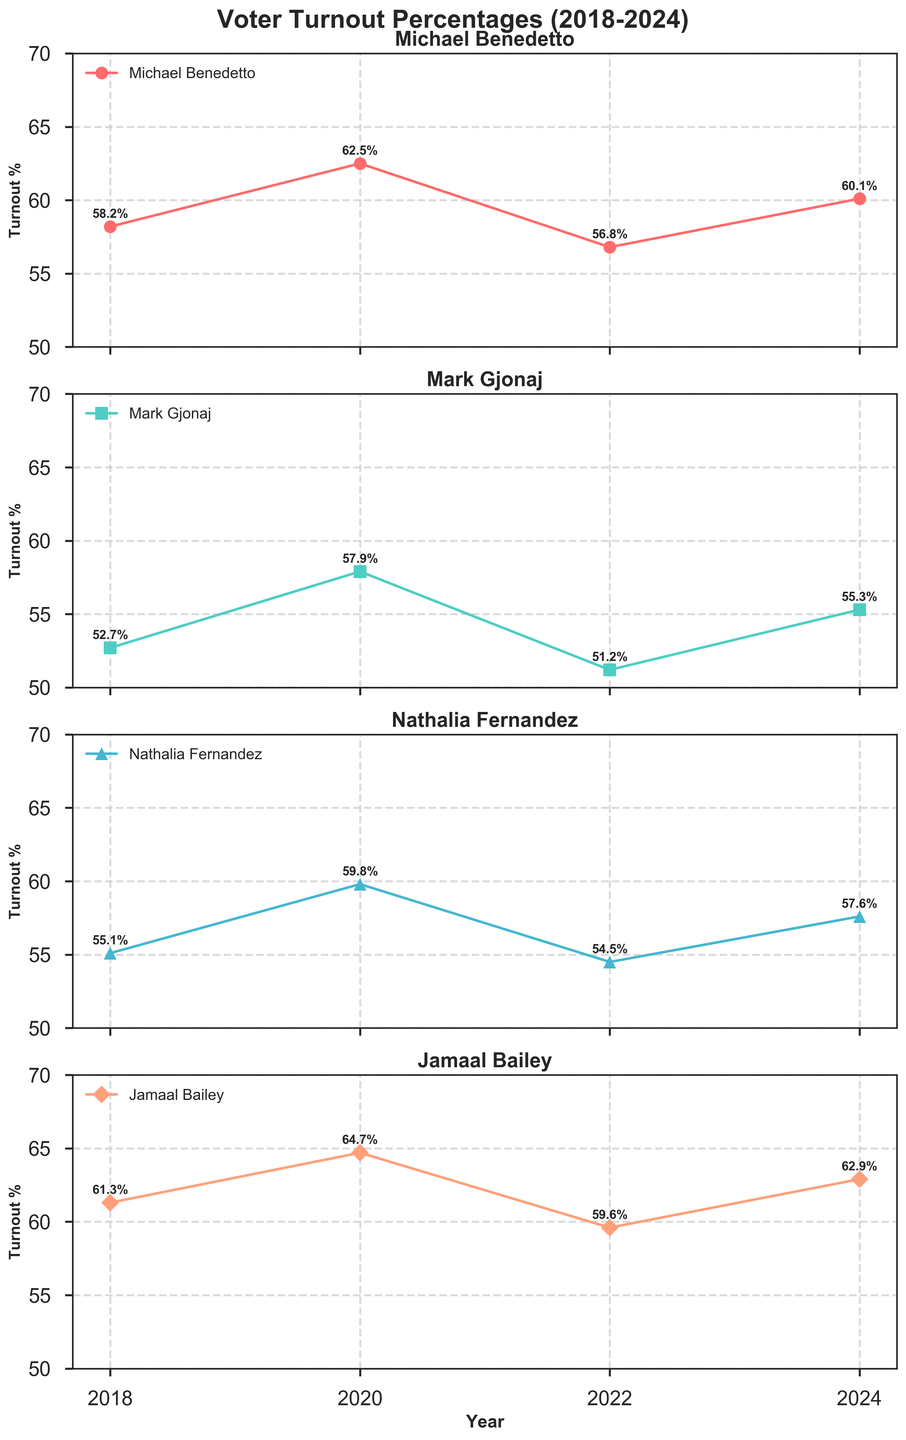What years are covered in the voter turnout data? The x-axis shows the years covered in the data, which are clearly labeled.
Answer: 2018-2024 Which candidate had the highest voter turnout in 2020? In the subplot for 2020, the turnout percentages for all candidates are marked. Jamaal Bailey has the highest percentage.
Answer: Jamaal Bailey By how much did Michael Benedetto's voter turnout change from 2018 to 2022? To find the change, subtract the 2018 turnout percentage (58.2%) from the 2022 turnout percentage (56.8%). This results in a change of -1.4%.
Answer: -1.4% Who had the lowest voter turnout percentage in 2022? Looking at the subplots for 2022, Mark Gjonaj had the lowest turnout percentage.
Answer: Mark Gjonaj What is the average voter turnout for Nathalia Fernandez over the years? Sum the turnout percentages for Nathalia Fernandez over the years and then divide by the number of years: (55.1 + 59.8 + 54.5 + 57.6) / 4 = 56.75%.
Answer: 56.75% Is there any year when Michael Benedetto had the highest voter turnout among all candidates? Compare Michael Benedetto's turnout percentage against other candidates' on the same subplot for each year. In 2020, Jamaal Bailey had the highest turnout. So no, there was no year when Michael Benedetto had the highest turnout.
Answer: No Which candidate showed the most consistent voter turnout percentage (least variation) over the years? Look at the voter turnout lines; the candidate whose lines have the smallest fluctuations (least steep changes) is the most consistent. Nathalia Fernandez's line seems the least variable.
Answer: Nathalia Fernandez What general trend can be seen in voter turnout percentages for Michael Benedetto from 2018 to 2024? Michael Benedetto’s voter turnout increased from 2018 to 2020, decreased in 2022, and increased again in 2024, indicating a fluctuating trend.
Answer: Fluctuating trend How did the voter turnout percentage for Jamaal Bailey compare between 2018 and 2024? Check the turnout percentages for Jamaal Bailey in 2018 and 2024 (61.3% and 62.9%, respectively) and note the increase.
Answer: Increased Which candidate had the lowest voter turnout in 2018, and how much was it? In the subplot for 2018, Mark Gjonaj had the lowest turnout at 52.7%.
Answer: Mark Gjonaj, 52.7% 